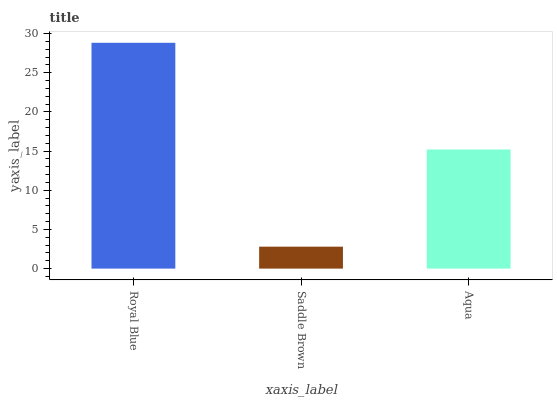Is Saddle Brown the minimum?
Answer yes or no. Yes. Is Royal Blue the maximum?
Answer yes or no. Yes. Is Aqua the minimum?
Answer yes or no. No. Is Aqua the maximum?
Answer yes or no. No. Is Aqua greater than Saddle Brown?
Answer yes or no. Yes. Is Saddle Brown less than Aqua?
Answer yes or no. Yes. Is Saddle Brown greater than Aqua?
Answer yes or no. No. Is Aqua less than Saddle Brown?
Answer yes or no. No. Is Aqua the high median?
Answer yes or no. Yes. Is Aqua the low median?
Answer yes or no. Yes. Is Saddle Brown the high median?
Answer yes or no. No. Is Saddle Brown the low median?
Answer yes or no. No. 